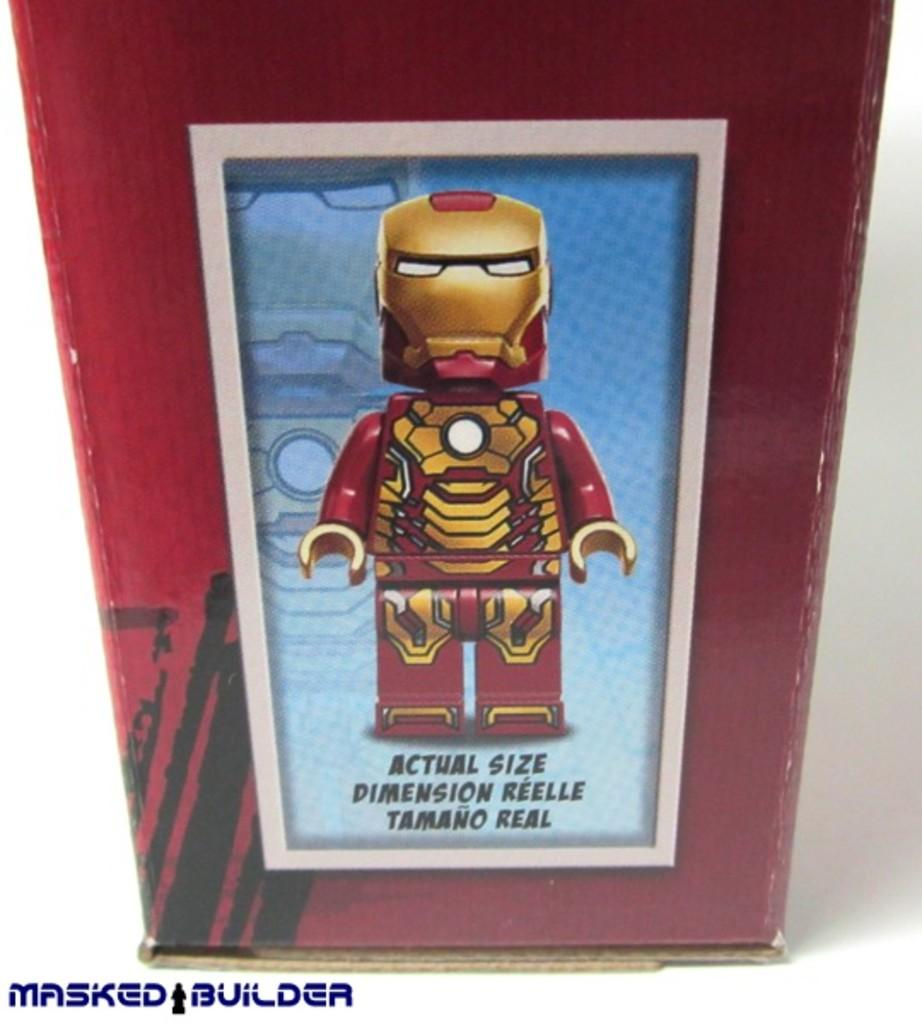<image>
Give a short and clear explanation of the subsequent image. A rendering of the actual size lego ironman action figure. 